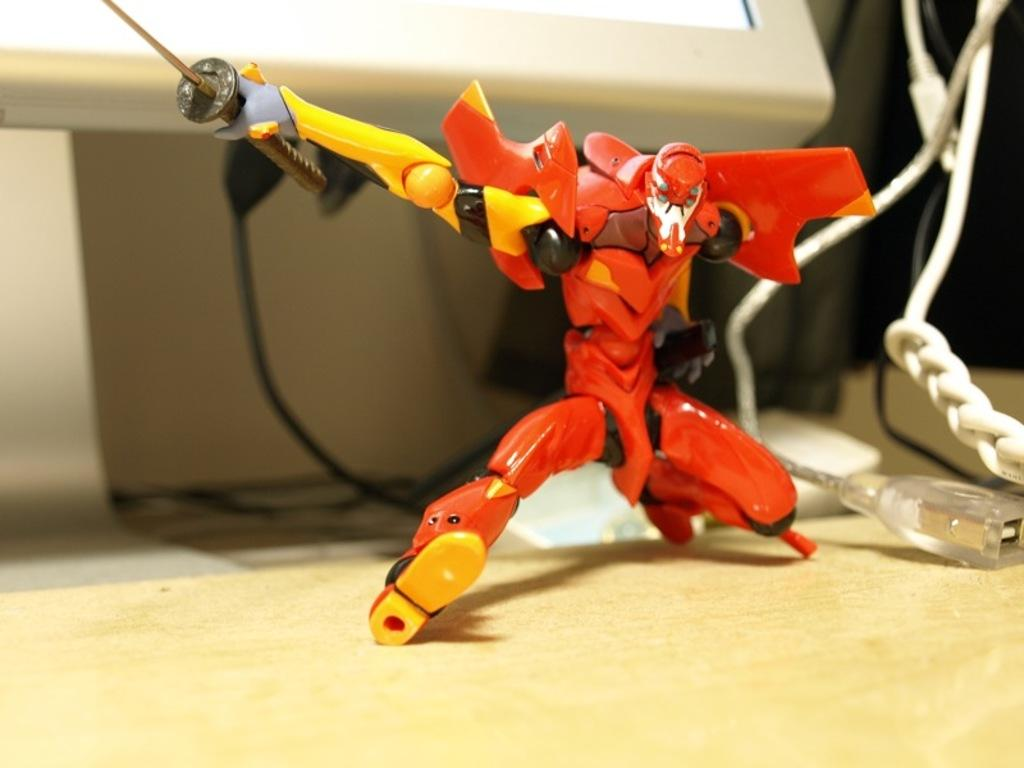What is located on the wooden surface in the image? There is a toy on a wooden surface in the image. What can be seen in the background of the image? There are wires and a stand visible in the background of the image. What is at the top of the image? There is a monitor at the top of the image. What type of fang can be seen on the toy in the image? There is no fang present on the toy in the image. 